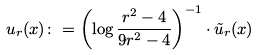Convert formula to latex. <formula><loc_0><loc_0><loc_500><loc_500>u _ { r } ( x ) \colon = \left ( \log \frac { r ^ { 2 } - 4 } { 9 r ^ { 2 } - 4 } \right ) ^ { - 1 } \cdot \tilde { u } _ { r } ( x )</formula> 